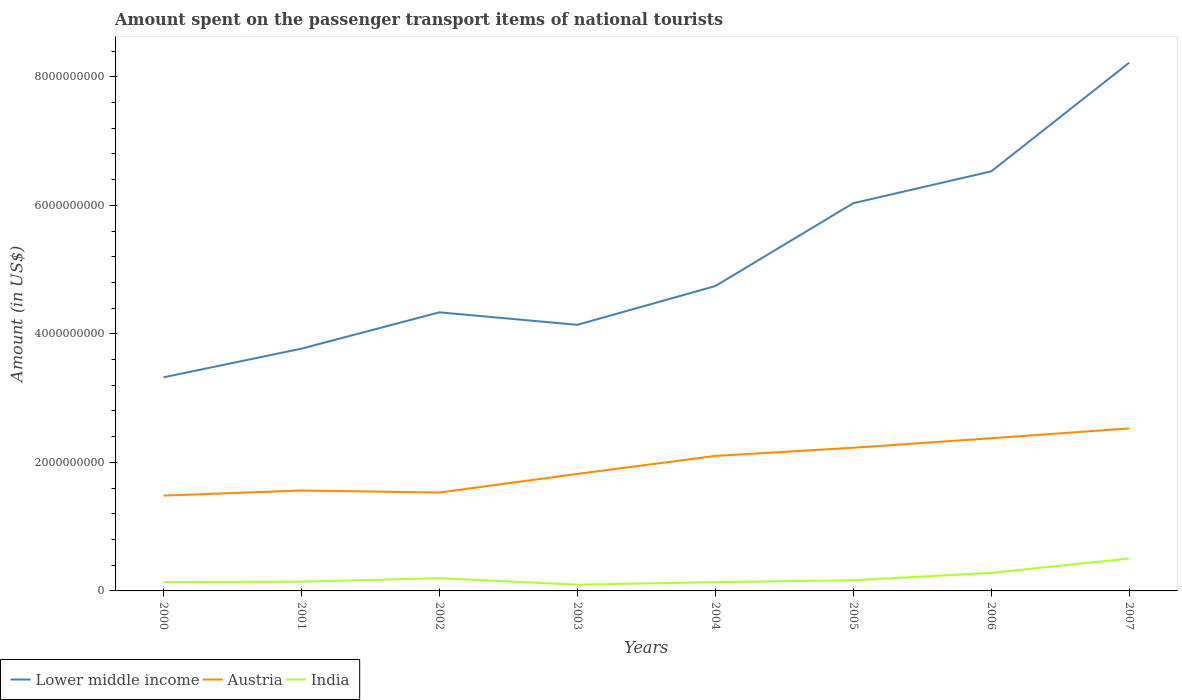How many different coloured lines are there?
Offer a terse response. 3. Does the line corresponding to Austria intersect with the line corresponding to Lower middle income?
Make the answer very short. No. Across all years, what is the maximum amount spent on the passenger transport items of national tourists in Austria?
Provide a short and direct response. 1.48e+09. What is the total amount spent on the passenger transport items of national tourists in Austria in the graph?
Keep it short and to the point. -4.07e+08. What is the difference between the highest and the second highest amount spent on the passenger transport items of national tourists in Lower middle income?
Your response must be concise. 4.90e+09. What is the difference between the highest and the lowest amount spent on the passenger transport items of national tourists in India?
Provide a succinct answer. 2. Is the amount spent on the passenger transport items of national tourists in Lower middle income strictly greater than the amount spent on the passenger transport items of national tourists in India over the years?
Provide a short and direct response. No. How many years are there in the graph?
Provide a short and direct response. 8. Are the values on the major ticks of Y-axis written in scientific E-notation?
Offer a terse response. No. Does the graph contain grids?
Keep it short and to the point. No. What is the title of the graph?
Make the answer very short. Amount spent on the passenger transport items of national tourists. What is the Amount (in US$) of Lower middle income in 2000?
Offer a very short reply. 3.32e+09. What is the Amount (in US$) of Austria in 2000?
Ensure brevity in your answer.  1.48e+09. What is the Amount (in US$) in India in 2000?
Your response must be concise. 1.38e+08. What is the Amount (in US$) of Lower middle income in 2001?
Offer a very short reply. 3.77e+09. What is the Amount (in US$) in Austria in 2001?
Keep it short and to the point. 1.56e+09. What is the Amount (in US$) of India in 2001?
Provide a short and direct response. 1.44e+08. What is the Amount (in US$) of Lower middle income in 2002?
Provide a succinct answer. 4.34e+09. What is the Amount (in US$) of Austria in 2002?
Provide a succinct answer. 1.53e+09. What is the Amount (in US$) in India in 2002?
Keep it short and to the point. 1.98e+08. What is the Amount (in US$) in Lower middle income in 2003?
Provide a short and direct response. 4.14e+09. What is the Amount (in US$) of Austria in 2003?
Offer a very short reply. 1.82e+09. What is the Amount (in US$) of India in 2003?
Offer a terse response. 9.70e+07. What is the Amount (in US$) of Lower middle income in 2004?
Offer a very short reply. 4.74e+09. What is the Amount (in US$) in Austria in 2004?
Provide a succinct answer. 2.10e+09. What is the Amount (in US$) in India in 2004?
Offer a terse response. 1.37e+08. What is the Amount (in US$) in Lower middle income in 2005?
Make the answer very short. 6.03e+09. What is the Amount (in US$) of Austria in 2005?
Your answer should be very brief. 2.23e+09. What is the Amount (in US$) of India in 2005?
Make the answer very short. 1.66e+08. What is the Amount (in US$) of Lower middle income in 2006?
Your answer should be compact. 6.53e+09. What is the Amount (in US$) of Austria in 2006?
Your response must be concise. 2.38e+09. What is the Amount (in US$) of India in 2006?
Offer a terse response. 2.81e+08. What is the Amount (in US$) of Lower middle income in 2007?
Your answer should be compact. 8.22e+09. What is the Amount (in US$) in Austria in 2007?
Your response must be concise. 2.53e+09. What is the Amount (in US$) in India in 2007?
Keep it short and to the point. 5.04e+08. Across all years, what is the maximum Amount (in US$) in Lower middle income?
Offer a very short reply. 8.22e+09. Across all years, what is the maximum Amount (in US$) in Austria?
Your response must be concise. 2.53e+09. Across all years, what is the maximum Amount (in US$) in India?
Your answer should be compact. 5.04e+08. Across all years, what is the minimum Amount (in US$) of Lower middle income?
Make the answer very short. 3.32e+09. Across all years, what is the minimum Amount (in US$) of Austria?
Provide a short and direct response. 1.48e+09. Across all years, what is the minimum Amount (in US$) in India?
Give a very brief answer. 9.70e+07. What is the total Amount (in US$) of Lower middle income in the graph?
Your answer should be very brief. 4.11e+1. What is the total Amount (in US$) of Austria in the graph?
Keep it short and to the point. 1.56e+1. What is the total Amount (in US$) of India in the graph?
Your answer should be compact. 1.66e+09. What is the difference between the Amount (in US$) in Lower middle income in 2000 and that in 2001?
Your answer should be compact. -4.46e+08. What is the difference between the Amount (in US$) in Austria in 2000 and that in 2001?
Provide a short and direct response. -8.00e+07. What is the difference between the Amount (in US$) in India in 2000 and that in 2001?
Give a very brief answer. -6.00e+06. What is the difference between the Amount (in US$) in Lower middle income in 2000 and that in 2002?
Provide a succinct answer. -1.01e+09. What is the difference between the Amount (in US$) in Austria in 2000 and that in 2002?
Your response must be concise. -4.80e+07. What is the difference between the Amount (in US$) in India in 2000 and that in 2002?
Make the answer very short. -6.00e+07. What is the difference between the Amount (in US$) of Lower middle income in 2000 and that in 2003?
Your answer should be very brief. -8.17e+08. What is the difference between the Amount (in US$) of Austria in 2000 and that in 2003?
Provide a succinct answer. -3.38e+08. What is the difference between the Amount (in US$) in India in 2000 and that in 2003?
Offer a terse response. 4.10e+07. What is the difference between the Amount (in US$) in Lower middle income in 2000 and that in 2004?
Give a very brief answer. -1.42e+09. What is the difference between the Amount (in US$) in Austria in 2000 and that in 2004?
Make the answer very short. -6.18e+08. What is the difference between the Amount (in US$) of India in 2000 and that in 2004?
Give a very brief answer. 1.00e+06. What is the difference between the Amount (in US$) in Lower middle income in 2000 and that in 2005?
Ensure brevity in your answer.  -2.71e+09. What is the difference between the Amount (in US$) of Austria in 2000 and that in 2005?
Your response must be concise. -7.45e+08. What is the difference between the Amount (in US$) in India in 2000 and that in 2005?
Your response must be concise. -2.80e+07. What is the difference between the Amount (in US$) in Lower middle income in 2000 and that in 2006?
Your response must be concise. -3.21e+09. What is the difference between the Amount (in US$) in Austria in 2000 and that in 2006?
Offer a very short reply. -8.93e+08. What is the difference between the Amount (in US$) of India in 2000 and that in 2006?
Offer a terse response. -1.43e+08. What is the difference between the Amount (in US$) of Lower middle income in 2000 and that in 2007?
Your response must be concise. -4.90e+09. What is the difference between the Amount (in US$) in Austria in 2000 and that in 2007?
Make the answer very short. -1.05e+09. What is the difference between the Amount (in US$) of India in 2000 and that in 2007?
Your response must be concise. -3.66e+08. What is the difference between the Amount (in US$) in Lower middle income in 2001 and that in 2002?
Offer a terse response. -5.65e+08. What is the difference between the Amount (in US$) of Austria in 2001 and that in 2002?
Make the answer very short. 3.20e+07. What is the difference between the Amount (in US$) of India in 2001 and that in 2002?
Offer a very short reply. -5.40e+07. What is the difference between the Amount (in US$) in Lower middle income in 2001 and that in 2003?
Provide a short and direct response. -3.71e+08. What is the difference between the Amount (in US$) in Austria in 2001 and that in 2003?
Make the answer very short. -2.58e+08. What is the difference between the Amount (in US$) of India in 2001 and that in 2003?
Your answer should be compact. 4.70e+07. What is the difference between the Amount (in US$) of Lower middle income in 2001 and that in 2004?
Ensure brevity in your answer.  -9.74e+08. What is the difference between the Amount (in US$) of Austria in 2001 and that in 2004?
Your response must be concise. -5.38e+08. What is the difference between the Amount (in US$) in Lower middle income in 2001 and that in 2005?
Provide a succinct answer. -2.26e+09. What is the difference between the Amount (in US$) of Austria in 2001 and that in 2005?
Keep it short and to the point. -6.65e+08. What is the difference between the Amount (in US$) of India in 2001 and that in 2005?
Give a very brief answer. -2.20e+07. What is the difference between the Amount (in US$) in Lower middle income in 2001 and that in 2006?
Make the answer very short. -2.76e+09. What is the difference between the Amount (in US$) in Austria in 2001 and that in 2006?
Offer a very short reply. -8.13e+08. What is the difference between the Amount (in US$) of India in 2001 and that in 2006?
Your response must be concise. -1.37e+08. What is the difference between the Amount (in US$) in Lower middle income in 2001 and that in 2007?
Offer a terse response. -4.45e+09. What is the difference between the Amount (in US$) of Austria in 2001 and that in 2007?
Provide a succinct answer. -9.66e+08. What is the difference between the Amount (in US$) in India in 2001 and that in 2007?
Provide a succinct answer. -3.60e+08. What is the difference between the Amount (in US$) in Lower middle income in 2002 and that in 2003?
Your response must be concise. 1.95e+08. What is the difference between the Amount (in US$) in Austria in 2002 and that in 2003?
Your answer should be compact. -2.90e+08. What is the difference between the Amount (in US$) in India in 2002 and that in 2003?
Provide a succinct answer. 1.01e+08. What is the difference between the Amount (in US$) of Lower middle income in 2002 and that in 2004?
Your answer should be compact. -4.09e+08. What is the difference between the Amount (in US$) of Austria in 2002 and that in 2004?
Keep it short and to the point. -5.70e+08. What is the difference between the Amount (in US$) of India in 2002 and that in 2004?
Your answer should be very brief. 6.10e+07. What is the difference between the Amount (in US$) in Lower middle income in 2002 and that in 2005?
Your answer should be very brief. -1.70e+09. What is the difference between the Amount (in US$) in Austria in 2002 and that in 2005?
Keep it short and to the point. -6.97e+08. What is the difference between the Amount (in US$) in India in 2002 and that in 2005?
Provide a succinct answer. 3.20e+07. What is the difference between the Amount (in US$) in Lower middle income in 2002 and that in 2006?
Offer a very short reply. -2.19e+09. What is the difference between the Amount (in US$) in Austria in 2002 and that in 2006?
Offer a terse response. -8.45e+08. What is the difference between the Amount (in US$) of India in 2002 and that in 2006?
Your answer should be very brief. -8.30e+07. What is the difference between the Amount (in US$) in Lower middle income in 2002 and that in 2007?
Provide a short and direct response. -3.88e+09. What is the difference between the Amount (in US$) in Austria in 2002 and that in 2007?
Provide a short and direct response. -9.98e+08. What is the difference between the Amount (in US$) of India in 2002 and that in 2007?
Offer a very short reply. -3.06e+08. What is the difference between the Amount (in US$) of Lower middle income in 2003 and that in 2004?
Your answer should be compact. -6.03e+08. What is the difference between the Amount (in US$) of Austria in 2003 and that in 2004?
Keep it short and to the point. -2.80e+08. What is the difference between the Amount (in US$) of India in 2003 and that in 2004?
Make the answer very short. -4.00e+07. What is the difference between the Amount (in US$) in Lower middle income in 2003 and that in 2005?
Provide a short and direct response. -1.89e+09. What is the difference between the Amount (in US$) in Austria in 2003 and that in 2005?
Your answer should be very brief. -4.07e+08. What is the difference between the Amount (in US$) in India in 2003 and that in 2005?
Make the answer very short. -6.90e+07. What is the difference between the Amount (in US$) of Lower middle income in 2003 and that in 2006?
Offer a terse response. -2.39e+09. What is the difference between the Amount (in US$) in Austria in 2003 and that in 2006?
Provide a succinct answer. -5.55e+08. What is the difference between the Amount (in US$) in India in 2003 and that in 2006?
Your answer should be very brief. -1.84e+08. What is the difference between the Amount (in US$) in Lower middle income in 2003 and that in 2007?
Your answer should be very brief. -4.08e+09. What is the difference between the Amount (in US$) in Austria in 2003 and that in 2007?
Provide a short and direct response. -7.08e+08. What is the difference between the Amount (in US$) in India in 2003 and that in 2007?
Your response must be concise. -4.07e+08. What is the difference between the Amount (in US$) in Lower middle income in 2004 and that in 2005?
Make the answer very short. -1.29e+09. What is the difference between the Amount (in US$) in Austria in 2004 and that in 2005?
Offer a very short reply. -1.27e+08. What is the difference between the Amount (in US$) in India in 2004 and that in 2005?
Make the answer very short. -2.90e+07. What is the difference between the Amount (in US$) of Lower middle income in 2004 and that in 2006?
Provide a short and direct response. -1.78e+09. What is the difference between the Amount (in US$) of Austria in 2004 and that in 2006?
Your answer should be very brief. -2.75e+08. What is the difference between the Amount (in US$) of India in 2004 and that in 2006?
Your answer should be compact. -1.44e+08. What is the difference between the Amount (in US$) in Lower middle income in 2004 and that in 2007?
Offer a terse response. -3.48e+09. What is the difference between the Amount (in US$) of Austria in 2004 and that in 2007?
Your answer should be very brief. -4.28e+08. What is the difference between the Amount (in US$) in India in 2004 and that in 2007?
Your response must be concise. -3.67e+08. What is the difference between the Amount (in US$) in Lower middle income in 2005 and that in 2006?
Offer a terse response. -4.95e+08. What is the difference between the Amount (in US$) in Austria in 2005 and that in 2006?
Your answer should be compact. -1.48e+08. What is the difference between the Amount (in US$) in India in 2005 and that in 2006?
Offer a very short reply. -1.15e+08. What is the difference between the Amount (in US$) in Lower middle income in 2005 and that in 2007?
Your response must be concise. -2.19e+09. What is the difference between the Amount (in US$) of Austria in 2005 and that in 2007?
Provide a short and direct response. -3.01e+08. What is the difference between the Amount (in US$) of India in 2005 and that in 2007?
Your answer should be very brief. -3.38e+08. What is the difference between the Amount (in US$) of Lower middle income in 2006 and that in 2007?
Your response must be concise. -1.69e+09. What is the difference between the Amount (in US$) in Austria in 2006 and that in 2007?
Your answer should be very brief. -1.53e+08. What is the difference between the Amount (in US$) of India in 2006 and that in 2007?
Ensure brevity in your answer.  -2.23e+08. What is the difference between the Amount (in US$) in Lower middle income in 2000 and the Amount (in US$) in Austria in 2001?
Ensure brevity in your answer.  1.76e+09. What is the difference between the Amount (in US$) of Lower middle income in 2000 and the Amount (in US$) of India in 2001?
Make the answer very short. 3.18e+09. What is the difference between the Amount (in US$) in Austria in 2000 and the Amount (in US$) in India in 2001?
Your answer should be compact. 1.34e+09. What is the difference between the Amount (in US$) in Lower middle income in 2000 and the Amount (in US$) in Austria in 2002?
Make the answer very short. 1.79e+09. What is the difference between the Amount (in US$) in Lower middle income in 2000 and the Amount (in US$) in India in 2002?
Your response must be concise. 3.13e+09. What is the difference between the Amount (in US$) of Austria in 2000 and the Amount (in US$) of India in 2002?
Provide a succinct answer. 1.28e+09. What is the difference between the Amount (in US$) in Lower middle income in 2000 and the Amount (in US$) in Austria in 2003?
Your response must be concise. 1.50e+09. What is the difference between the Amount (in US$) in Lower middle income in 2000 and the Amount (in US$) in India in 2003?
Offer a terse response. 3.23e+09. What is the difference between the Amount (in US$) of Austria in 2000 and the Amount (in US$) of India in 2003?
Provide a succinct answer. 1.39e+09. What is the difference between the Amount (in US$) of Lower middle income in 2000 and the Amount (in US$) of Austria in 2004?
Keep it short and to the point. 1.22e+09. What is the difference between the Amount (in US$) of Lower middle income in 2000 and the Amount (in US$) of India in 2004?
Keep it short and to the point. 3.19e+09. What is the difference between the Amount (in US$) in Austria in 2000 and the Amount (in US$) in India in 2004?
Provide a succinct answer. 1.35e+09. What is the difference between the Amount (in US$) in Lower middle income in 2000 and the Amount (in US$) in Austria in 2005?
Keep it short and to the point. 1.10e+09. What is the difference between the Amount (in US$) of Lower middle income in 2000 and the Amount (in US$) of India in 2005?
Your response must be concise. 3.16e+09. What is the difference between the Amount (in US$) of Austria in 2000 and the Amount (in US$) of India in 2005?
Offer a terse response. 1.32e+09. What is the difference between the Amount (in US$) in Lower middle income in 2000 and the Amount (in US$) in Austria in 2006?
Make the answer very short. 9.48e+08. What is the difference between the Amount (in US$) of Lower middle income in 2000 and the Amount (in US$) of India in 2006?
Offer a terse response. 3.04e+09. What is the difference between the Amount (in US$) of Austria in 2000 and the Amount (in US$) of India in 2006?
Make the answer very short. 1.20e+09. What is the difference between the Amount (in US$) in Lower middle income in 2000 and the Amount (in US$) in Austria in 2007?
Keep it short and to the point. 7.95e+08. What is the difference between the Amount (in US$) in Lower middle income in 2000 and the Amount (in US$) in India in 2007?
Ensure brevity in your answer.  2.82e+09. What is the difference between the Amount (in US$) of Austria in 2000 and the Amount (in US$) of India in 2007?
Make the answer very short. 9.79e+08. What is the difference between the Amount (in US$) in Lower middle income in 2001 and the Amount (in US$) in Austria in 2002?
Offer a very short reply. 2.24e+09. What is the difference between the Amount (in US$) of Lower middle income in 2001 and the Amount (in US$) of India in 2002?
Provide a short and direct response. 3.57e+09. What is the difference between the Amount (in US$) in Austria in 2001 and the Amount (in US$) in India in 2002?
Give a very brief answer. 1.36e+09. What is the difference between the Amount (in US$) of Lower middle income in 2001 and the Amount (in US$) of Austria in 2003?
Give a very brief answer. 1.95e+09. What is the difference between the Amount (in US$) of Lower middle income in 2001 and the Amount (in US$) of India in 2003?
Make the answer very short. 3.67e+09. What is the difference between the Amount (in US$) in Austria in 2001 and the Amount (in US$) in India in 2003?
Offer a terse response. 1.47e+09. What is the difference between the Amount (in US$) of Lower middle income in 2001 and the Amount (in US$) of Austria in 2004?
Your answer should be very brief. 1.67e+09. What is the difference between the Amount (in US$) in Lower middle income in 2001 and the Amount (in US$) in India in 2004?
Your answer should be very brief. 3.63e+09. What is the difference between the Amount (in US$) of Austria in 2001 and the Amount (in US$) of India in 2004?
Provide a short and direct response. 1.43e+09. What is the difference between the Amount (in US$) in Lower middle income in 2001 and the Amount (in US$) in Austria in 2005?
Make the answer very short. 1.54e+09. What is the difference between the Amount (in US$) in Lower middle income in 2001 and the Amount (in US$) in India in 2005?
Give a very brief answer. 3.60e+09. What is the difference between the Amount (in US$) in Austria in 2001 and the Amount (in US$) in India in 2005?
Your response must be concise. 1.40e+09. What is the difference between the Amount (in US$) of Lower middle income in 2001 and the Amount (in US$) of Austria in 2006?
Offer a terse response. 1.39e+09. What is the difference between the Amount (in US$) of Lower middle income in 2001 and the Amount (in US$) of India in 2006?
Keep it short and to the point. 3.49e+09. What is the difference between the Amount (in US$) of Austria in 2001 and the Amount (in US$) of India in 2006?
Ensure brevity in your answer.  1.28e+09. What is the difference between the Amount (in US$) in Lower middle income in 2001 and the Amount (in US$) in Austria in 2007?
Provide a short and direct response. 1.24e+09. What is the difference between the Amount (in US$) of Lower middle income in 2001 and the Amount (in US$) of India in 2007?
Provide a short and direct response. 3.27e+09. What is the difference between the Amount (in US$) of Austria in 2001 and the Amount (in US$) of India in 2007?
Offer a terse response. 1.06e+09. What is the difference between the Amount (in US$) in Lower middle income in 2002 and the Amount (in US$) in Austria in 2003?
Make the answer very short. 2.51e+09. What is the difference between the Amount (in US$) of Lower middle income in 2002 and the Amount (in US$) of India in 2003?
Your response must be concise. 4.24e+09. What is the difference between the Amount (in US$) in Austria in 2002 and the Amount (in US$) in India in 2003?
Make the answer very short. 1.43e+09. What is the difference between the Amount (in US$) of Lower middle income in 2002 and the Amount (in US$) of Austria in 2004?
Your answer should be very brief. 2.23e+09. What is the difference between the Amount (in US$) of Lower middle income in 2002 and the Amount (in US$) of India in 2004?
Your response must be concise. 4.20e+09. What is the difference between the Amount (in US$) in Austria in 2002 and the Amount (in US$) in India in 2004?
Your answer should be very brief. 1.39e+09. What is the difference between the Amount (in US$) of Lower middle income in 2002 and the Amount (in US$) of Austria in 2005?
Provide a short and direct response. 2.11e+09. What is the difference between the Amount (in US$) of Lower middle income in 2002 and the Amount (in US$) of India in 2005?
Provide a short and direct response. 4.17e+09. What is the difference between the Amount (in US$) in Austria in 2002 and the Amount (in US$) in India in 2005?
Give a very brief answer. 1.36e+09. What is the difference between the Amount (in US$) in Lower middle income in 2002 and the Amount (in US$) in Austria in 2006?
Offer a terse response. 1.96e+09. What is the difference between the Amount (in US$) in Lower middle income in 2002 and the Amount (in US$) in India in 2006?
Offer a terse response. 4.05e+09. What is the difference between the Amount (in US$) in Austria in 2002 and the Amount (in US$) in India in 2006?
Offer a very short reply. 1.25e+09. What is the difference between the Amount (in US$) of Lower middle income in 2002 and the Amount (in US$) of Austria in 2007?
Make the answer very short. 1.81e+09. What is the difference between the Amount (in US$) in Lower middle income in 2002 and the Amount (in US$) in India in 2007?
Provide a succinct answer. 3.83e+09. What is the difference between the Amount (in US$) in Austria in 2002 and the Amount (in US$) in India in 2007?
Your answer should be very brief. 1.03e+09. What is the difference between the Amount (in US$) in Lower middle income in 2003 and the Amount (in US$) in Austria in 2004?
Your response must be concise. 2.04e+09. What is the difference between the Amount (in US$) of Lower middle income in 2003 and the Amount (in US$) of India in 2004?
Your answer should be compact. 4.00e+09. What is the difference between the Amount (in US$) of Austria in 2003 and the Amount (in US$) of India in 2004?
Provide a short and direct response. 1.68e+09. What is the difference between the Amount (in US$) of Lower middle income in 2003 and the Amount (in US$) of Austria in 2005?
Your answer should be very brief. 1.91e+09. What is the difference between the Amount (in US$) in Lower middle income in 2003 and the Amount (in US$) in India in 2005?
Offer a terse response. 3.97e+09. What is the difference between the Amount (in US$) in Austria in 2003 and the Amount (in US$) in India in 2005?
Make the answer very short. 1.66e+09. What is the difference between the Amount (in US$) of Lower middle income in 2003 and the Amount (in US$) of Austria in 2006?
Offer a terse response. 1.76e+09. What is the difference between the Amount (in US$) in Lower middle income in 2003 and the Amount (in US$) in India in 2006?
Offer a very short reply. 3.86e+09. What is the difference between the Amount (in US$) in Austria in 2003 and the Amount (in US$) in India in 2006?
Offer a very short reply. 1.54e+09. What is the difference between the Amount (in US$) in Lower middle income in 2003 and the Amount (in US$) in Austria in 2007?
Your answer should be very brief. 1.61e+09. What is the difference between the Amount (in US$) in Lower middle income in 2003 and the Amount (in US$) in India in 2007?
Your answer should be very brief. 3.64e+09. What is the difference between the Amount (in US$) of Austria in 2003 and the Amount (in US$) of India in 2007?
Your answer should be compact. 1.32e+09. What is the difference between the Amount (in US$) in Lower middle income in 2004 and the Amount (in US$) in Austria in 2005?
Your response must be concise. 2.52e+09. What is the difference between the Amount (in US$) of Lower middle income in 2004 and the Amount (in US$) of India in 2005?
Ensure brevity in your answer.  4.58e+09. What is the difference between the Amount (in US$) in Austria in 2004 and the Amount (in US$) in India in 2005?
Your answer should be compact. 1.94e+09. What is the difference between the Amount (in US$) of Lower middle income in 2004 and the Amount (in US$) of Austria in 2006?
Provide a short and direct response. 2.37e+09. What is the difference between the Amount (in US$) of Lower middle income in 2004 and the Amount (in US$) of India in 2006?
Your answer should be compact. 4.46e+09. What is the difference between the Amount (in US$) of Austria in 2004 and the Amount (in US$) of India in 2006?
Your answer should be very brief. 1.82e+09. What is the difference between the Amount (in US$) in Lower middle income in 2004 and the Amount (in US$) in Austria in 2007?
Your answer should be very brief. 2.22e+09. What is the difference between the Amount (in US$) in Lower middle income in 2004 and the Amount (in US$) in India in 2007?
Your response must be concise. 4.24e+09. What is the difference between the Amount (in US$) of Austria in 2004 and the Amount (in US$) of India in 2007?
Keep it short and to the point. 1.60e+09. What is the difference between the Amount (in US$) in Lower middle income in 2005 and the Amount (in US$) in Austria in 2006?
Offer a terse response. 3.66e+09. What is the difference between the Amount (in US$) in Lower middle income in 2005 and the Amount (in US$) in India in 2006?
Your response must be concise. 5.75e+09. What is the difference between the Amount (in US$) of Austria in 2005 and the Amount (in US$) of India in 2006?
Offer a very short reply. 1.95e+09. What is the difference between the Amount (in US$) in Lower middle income in 2005 and the Amount (in US$) in Austria in 2007?
Give a very brief answer. 3.50e+09. What is the difference between the Amount (in US$) in Lower middle income in 2005 and the Amount (in US$) in India in 2007?
Offer a very short reply. 5.53e+09. What is the difference between the Amount (in US$) of Austria in 2005 and the Amount (in US$) of India in 2007?
Offer a terse response. 1.72e+09. What is the difference between the Amount (in US$) of Lower middle income in 2006 and the Amount (in US$) of Austria in 2007?
Give a very brief answer. 4.00e+09. What is the difference between the Amount (in US$) of Lower middle income in 2006 and the Amount (in US$) of India in 2007?
Keep it short and to the point. 6.02e+09. What is the difference between the Amount (in US$) in Austria in 2006 and the Amount (in US$) in India in 2007?
Give a very brief answer. 1.87e+09. What is the average Amount (in US$) in Lower middle income per year?
Your answer should be compact. 5.14e+09. What is the average Amount (in US$) of Austria per year?
Your answer should be compact. 1.95e+09. What is the average Amount (in US$) of India per year?
Provide a short and direct response. 2.08e+08. In the year 2000, what is the difference between the Amount (in US$) of Lower middle income and Amount (in US$) of Austria?
Provide a short and direct response. 1.84e+09. In the year 2000, what is the difference between the Amount (in US$) in Lower middle income and Amount (in US$) in India?
Offer a very short reply. 3.19e+09. In the year 2000, what is the difference between the Amount (in US$) in Austria and Amount (in US$) in India?
Your response must be concise. 1.34e+09. In the year 2001, what is the difference between the Amount (in US$) in Lower middle income and Amount (in US$) in Austria?
Ensure brevity in your answer.  2.21e+09. In the year 2001, what is the difference between the Amount (in US$) in Lower middle income and Amount (in US$) in India?
Your answer should be compact. 3.63e+09. In the year 2001, what is the difference between the Amount (in US$) in Austria and Amount (in US$) in India?
Keep it short and to the point. 1.42e+09. In the year 2002, what is the difference between the Amount (in US$) in Lower middle income and Amount (in US$) in Austria?
Give a very brief answer. 2.80e+09. In the year 2002, what is the difference between the Amount (in US$) in Lower middle income and Amount (in US$) in India?
Provide a succinct answer. 4.14e+09. In the year 2002, what is the difference between the Amount (in US$) in Austria and Amount (in US$) in India?
Keep it short and to the point. 1.33e+09. In the year 2003, what is the difference between the Amount (in US$) of Lower middle income and Amount (in US$) of Austria?
Keep it short and to the point. 2.32e+09. In the year 2003, what is the difference between the Amount (in US$) in Lower middle income and Amount (in US$) in India?
Give a very brief answer. 4.04e+09. In the year 2003, what is the difference between the Amount (in US$) in Austria and Amount (in US$) in India?
Give a very brief answer. 1.72e+09. In the year 2004, what is the difference between the Amount (in US$) in Lower middle income and Amount (in US$) in Austria?
Your response must be concise. 2.64e+09. In the year 2004, what is the difference between the Amount (in US$) of Lower middle income and Amount (in US$) of India?
Your response must be concise. 4.61e+09. In the year 2004, what is the difference between the Amount (in US$) of Austria and Amount (in US$) of India?
Keep it short and to the point. 1.96e+09. In the year 2005, what is the difference between the Amount (in US$) in Lower middle income and Amount (in US$) in Austria?
Keep it short and to the point. 3.81e+09. In the year 2005, what is the difference between the Amount (in US$) in Lower middle income and Amount (in US$) in India?
Offer a very short reply. 5.87e+09. In the year 2005, what is the difference between the Amount (in US$) in Austria and Amount (in US$) in India?
Provide a succinct answer. 2.06e+09. In the year 2006, what is the difference between the Amount (in US$) in Lower middle income and Amount (in US$) in Austria?
Provide a succinct answer. 4.15e+09. In the year 2006, what is the difference between the Amount (in US$) of Lower middle income and Amount (in US$) of India?
Offer a very short reply. 6.25e+09. In the year 2006, what is the difference between the Amount (in US$) of Austria and Amount (in US$) of India?
Provide a short and direct response. 2.10e+09. In the year 2007, what is the difference between the Amount (in US$) in Lower middle income and Amount (in US$) in Austria?
Ensure brevity in your answer.  5.69e+09. In the year 2007, what is the difference between the Amount (in US$) of Lower middle income and Amount (in US$) of India?
Offer a very short reply. 7.72e+09. In the year 2007, what is the difference between the Amount (in US$) in Austria and Amount (in US$) in India?
Offer a very short reply. 2.02e+09. What is the ratio of the Amount (in US$) in Lower middle income in 2000 to that in 2001?
Your response must be concise. 0.88. What is the ratio of the Amount (in US$) in Austria in 2000 to that in 2001?
Ensure brevity in your answer.  0.95. What is the ratio of the Amount (in US$) in Lower middle income in 2000 to that in 2002?
Provide a short and direct response. 0.77. What is the ratio of the Amount (in US$) of Austria in 2000 to that in 2002?
Your answer should be very brief. 0.97. What is the ratio of the Amount (in US$) of India in 2000 to that in 2002?
Your response must be concise. 0.7. What is the ratio of the Amount (in US$) in Lower middle income in 2000 to that in 2003?
Keep it short and to the point. 0.8. What is the ratio of the Amount (in US$) of Austria in 2000 to that in 2003?
Provide a short and direct response. 0.81. What is the ratio of the Amount (in US$) of India in 2000 to that in 2003?
Keep it short and to the point. 1.42. What is the ratio of the Amount (in US$) in Lower middle income in 2000 to that in 2004?
Your answer should be very brief. 0.7. What is the ratio of the Amount (in US$) in Austria in 2000 to that in 2004?
Provide a short and direct response. 0.71. What is the ratio of the Amount (in US$) in India in 2000 to that in 2004?
Your answer should be very brief. 1.01. What is the ratio of the Amount (in US$) of Lower middle income in 2000 to that in 2005?
Provide a short and direct response. 0.55. What is the ratio of the Amount (in US$) in Austria in 2000 to that in 2005?
Provide a succinct answer. 0.67. What is the ratio of the Amount (in US$) of India in 2000 to that in 2005?
Offer a terse response. 0.83. What is the ratio of the Amount (in US$) in Lower middle income in 2000 to that in 2006?
Ensure brevity in your answer.  0.51. What is the ratio of the Amount (in US$) of Austria in 2000 to that in 2006?
Make the answer very short. 0.62. What is the ratio of the Amount (in US$) in India in 2000 to that in 2006?
Make the answer very short. 0.49. What is the ratio of the Amount (in US$) of Lower middle income in 2000 to that in 2007?
Ensure brevity in your answer.  0.4. What is the ratio of the Amount (in US$) in Austria in 2000 to that in 2007?
Ensure brevity in your answer.  0.59. What is the ratio of the Amount (in US$) in India in 2000 to that in 2007?
Ensure brevity in your answer.  0.27. What is the ratio of the Amount (in US$) in Lower middle income in 2001 to that in 2002?
Your answer should be compact. 0.87. What is the ratio of the Amount (in US$) in Austria in 2001 to that in 2002?
Your answer should be very brief. 1.02. What is the ratio of the Amount (in US$) in India in 2001 to that in 2002?
Your response must be concise. 0.73. What is the ratio of the Amount (in US$) in Lower middle income in 2001 to that in 2003?
Give a very brief answer. 0.91. What is the ratio of the Amount (in US$) of Austria in 2001 to that in 2003?
Provide a short and direct response. 0.86. What is the ratio of the Amount (in US$) of India in 2001 to that in 2003?
Offer a terse response. 1.48. What is the ratio of the Amount (in US$) in Lower middle income in 2001 to that in 2004?
Offer a terse response. 0.79. What is the ratio of the Amount (in US$) in Austria in 2001 to that in 2004?
Offer a terse response. 0.74. What is the ratio of the Amount (in US$) in India in 2001 to that in 2004?
Offer a terse response. 1.05. What is the ratio of the Amount (in US$) of Lower middle income in 2001 to that in 2005?
Ensure brevity in your answer.  0.62. What is the ratio of the Amount (in US$) of Austria in 2001 to that in 2005?
Your response must be concise. 0.7. What is the ratio of the Amount (in US$) of India in 2001 to that in 2005?
Offer a terse response. 0.87. What is the ratio of the Amount (in US$) of Lower middle income in 2001 to that in 2006?
Make the answer very short. 0.58. What is the ratio of the Amount (in US$) of Austria in 2001 to that in 2006?
Provide a short and direct response. 0.66. What is the ratio of the Amount (in US$) in India in 2001 to that in 2006?
Make the answer very short. 0.51. What is the ratio of the Amount (in US$) of Lower middle income in 2001 to that in 2007?
Offer a very short reply. 0.46. What is the ratio of the Amount (in US$) of Austria in 2001 to that in 2007?
Your answer should be compact. 0.62. What is the ratio of the Amount (in US$) of India in 2001 to that in 2007?
Keep it short and to the point. 0.29. What is the ratio of the Amount (in US$) of Lower middle income in 2002 to that in 2003?
Make the answer very short. 1.05. What is the ratio of the Amount (in US$) in Austria in 2002 to that in 2003?
Offer a terse response. 0.84. What is the ratio of the Amount (in US$) of India in 2002 to that in 2003?
Offer a very short reply. 2.04. What is the ratio of the Amount (in US$) of Lower middle income in 2002 to that in 2004?
Give a very brief answer. 0.91. What is the ratio of the Amount (in US$) in Austria in 2002 to that in 2004?
Give a very brief answer. 0.73. What is the ratio of the Amount (in US$) of India in 2002 to that in 2004?
Your answer should be compact. 1.45. What is the ratio of the Amount (in US$) of Lower middle income in 2002 to that in 2005?
Your answer should be very brief. 0.72. What is the ratio of the Amount (in US$) in Austria in 2002 to that in 2005?
Your response must be concise. 0.69. What is the ratio of the Amount (in US$) of India in 2002 to that in 2005?
Your response must be concise. 1.19. What is the ratio of the Amount (in US$) in Lower middle income in 2002 to that in 2006?
Offer a very short reply. 0.66. What is the ratio of the Amount (in US$) of Austria in 2002 to that in 2006?
Offer a terse response. 0.64. What is the ratio of the Amount (in US$) of India in 2002 to that in 2006?
Your answer should be very brief. 0.7. What is the ratio of the Amount (in US$) of Lower middle income in 2002 to that in 2007?
Provide a short and direct response. 0.53. What is the ratio of the Amount (in US$) in Austria in 2002 to that in 2007?
Your answer should be very brief. 0.61. What is the ratio of the Amount (in US$) of India in 2002 to that in 2007?
Offer a very short reply. 0.39. What is the ratio of the Amount (in US$) in Lower middle income in 2003 to that in 2004?
Keep it short and to the point. 0.87. What is the ratio of the Amount (in US$) of Austria in 2003 to that in 2004?
Provide a succinct answer. 0.87. What is the ratio of the Amount (in US$) in India in 2003 to that in 2004?
Provide a short and direct response. 0.71. What is the ratio of the Amount (in US$) of Lower middle income in 2003 to that in 2005?
Offer a very short reply. 0.69. What is the ratio of the Amount (in US$) in Austria in 2003 to that in 2005?
Give a very brief answer. 0.82. What is the ratio of the Amount (in US$) of India in 2003 to that in 2005?
Your answer should be very brief. 0.58. What is the ratio of the Amount (in US$) in Lower middle income in 2003 to that in 2006?
Your answer should be compact. 0.63. What is the ratio of the Amount (in US$) of Austria in 2003 to that in 2006?
Provide a short and direct response. 0.77. What is the ratio of the Amount (in US$) in India in 2003 to that in 2006?
Provide a short and direct response. 0.35. What is the ratio of the Amount (in US$) of Lower middle income in 2003 to that in 2007?
Offer a very short reply. 0.5. What is the ratio of the Amount (in US$) of Austria in 2003 to that in 2007?
Your answer should be compact. 0.72. What is the ratio of the Amount (in US$) of India in 2003 to that in 2007?
Your answer should be compact. 0.19. What is the ratio of the Amount (in US$) of Lower middle income in 2004 to that in 2005?
Provide a short and direct response. 0.79. What is the ratio of the Amount (in US$) in Austria in 2004 to that in 2005?
Offer a terse response. 0.94. What is the ratio of the Amount (in US$) in India in 2004 to that in 2005?
Provide a succinct answer. 0.83. What is the ratio of the Amount (in US$) of Lower middle income in 2004 to that in 2006?
Offer a terse response. 0.73. What is the ratio of the Amount (in US$) in Austria in 2004 to that in 2006?
Your answer should be compact. 0.88. What is the ratio of the Amount (in US$) in India in 2004 to that in 2006?
Give a very brief answer. 0.49. What is the ratio of the Amount (in US$) in Lower middle income in 2004 to that in 2007?
Keep it short and to the point. 0.58. What is the ratio of the Amount (in US$) in Austria in 2004 to that in 2007?
Make the answer very short. 0.83. What is the ratio of the Amount (in US$) in India in 2004 to that in 2007?
Make the answer very short. 0.27. What is the ratio of the Amount (in US$) of Lower middle income in 2005 to that in 2006?
Your response must be concise. 0.92. What is the ratio of the Amount (in US$) of Austria in 2005 to that in 2006?
Ensure brevity in your answer.  0.94. What is the ratio of the Amount (in US$) in India in 2005 to that in 2006?
Give a very brief answer. 0.59. What is the ratio of the Amount (in US$) of Lower middle income in 2005 to that in 2007?
Provide a short and direct response. 0.73. What is the ratio of the Amount (in US$) of Austria in 2005 to that in 2007?
Offer a terse response. 0.88. What is the ratio of the Amount (in US$) in India in 2005 to that in 2007?
Provide a short and direct response. 0.33. What is the ratio of the Amount (in US$) in Lower middle income in 2006 to that in 2007?
Make the answer very short. 0.79. What is the ratio of the Amount (in US$) in Austria in 2006 to that in 2007?
Offer a terse response. 0.94. What is the ratio of the Amount (in US$) of India in 2006 to that in 2007?
Ensure brevity in your answer.  0.56. What is the difference between the highest and the second highest Amount (in US$) in Lower middle income?
Offer a very short reply. 1.69e+09. What is the difference between the highest and the second highest Amount (in US$) of Austria?
Offer a terse response. 1.53e+08. What is the difference between the highest and the second highest Amount (in US$) of India?
Your response must be concise. 2.23e+08. What is the difference between the highest and the lowest Amount (in US$) in Lower middle income?
Ensure brevity in your answer.  4.90e+09. What is the difference between the highest and the lowest Amount (in US$) in Austria?
Provide a succinct answer. 1.05e+09. What is the difference between the highest and the lowest Amount (in US$) in India?
Provide a succinct answer. 4.07e+08. 